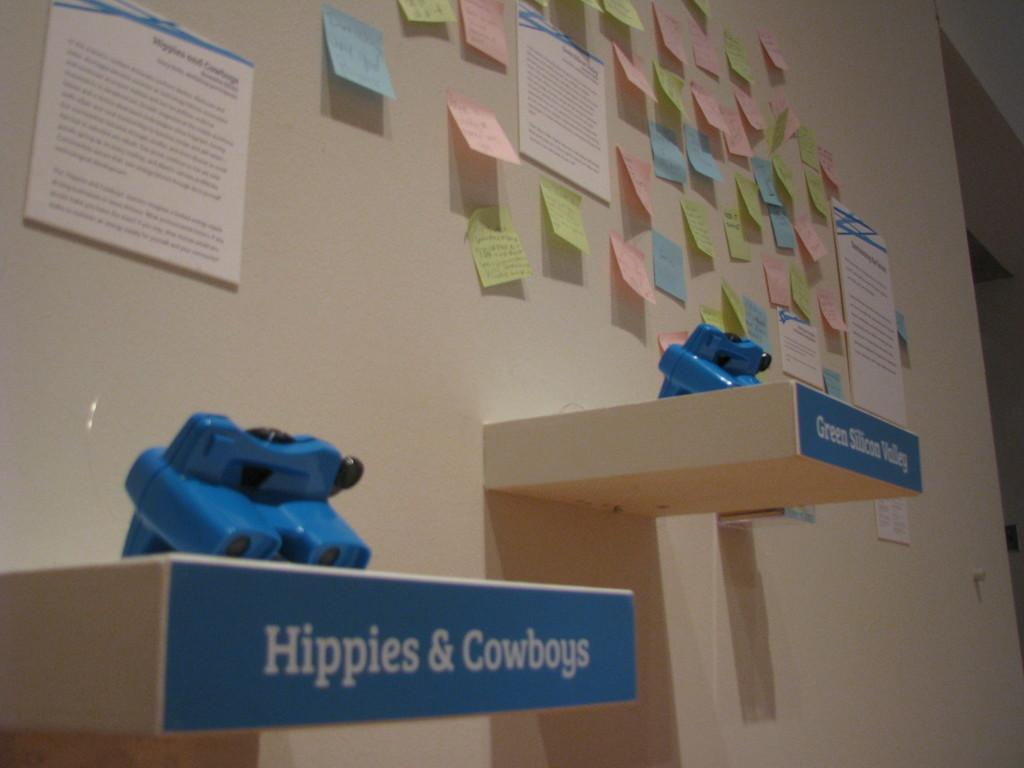What is the primary subject of the image? The primary subject of the image is many papers. How are the papers arranged in the image? The papers are stuck on the wall. Can you tell me how the dog is experiencing pleasure in the image? There is no dog present in the image, so it is not possible to determine how a dog might be experiencing pleasure. 